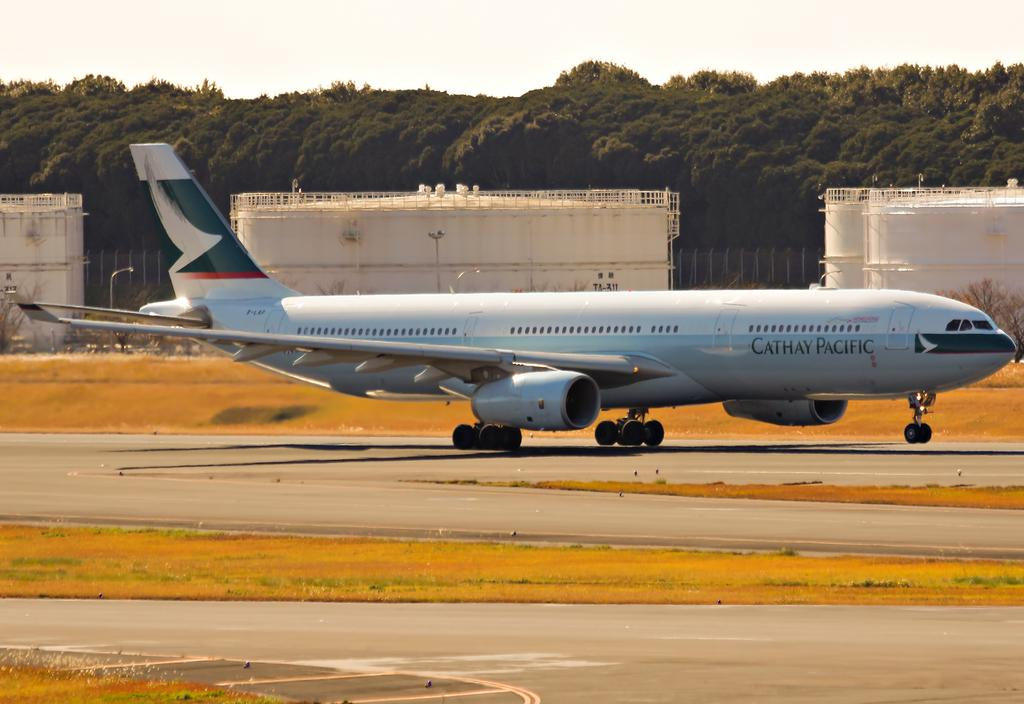What is the main subject of the image? The main subject of the image is an airplane on the runway. What can be seen in the background of the image? In the distance, there are buildings and dense trees visible. What type of wrench is being used to fix the airplane in the image? There is no wrench present in the image, and the airplane does not appear to be undergoing any maintenance or repairs. 